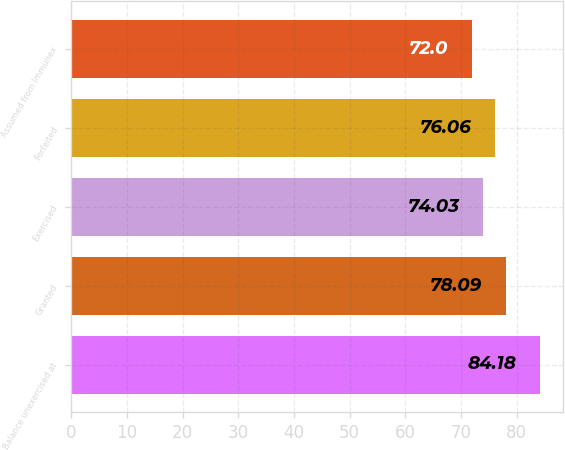<chart> <loc_0><loc_0><loc_500><loc_500><bar_chart><fcel>Balance unexercised at<fcel>Granted<fcel>Exercised<fcel>Forfeited<fcel>Assumed from Immunex<nl><fcel>84.18<fcel>78.09<fcel>74.03<fcel>76.06<fcel>72<nl></chart> 